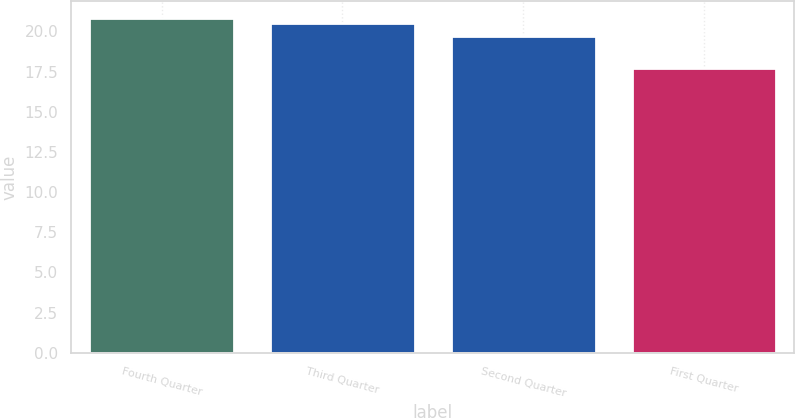<chart> <loc_0><loc_0><loc_500><loc_500><bar_chart><fcel>Fourth Quarter<fcel>Third Quarter<fcel>Second Quarter<fcel>First Quarter<nl><fcel>20.85<fcel>20.54<fcel>19.69<fcel>17.75<nl></chart> 